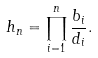Convert formula to latex. <formula><loc_0><loc_0><loc_500><loc_500>h _ { n } = \prod _ { i = 1 } ^ { n } \frac { b _ { i } } { d _ { i } } .</formula> 